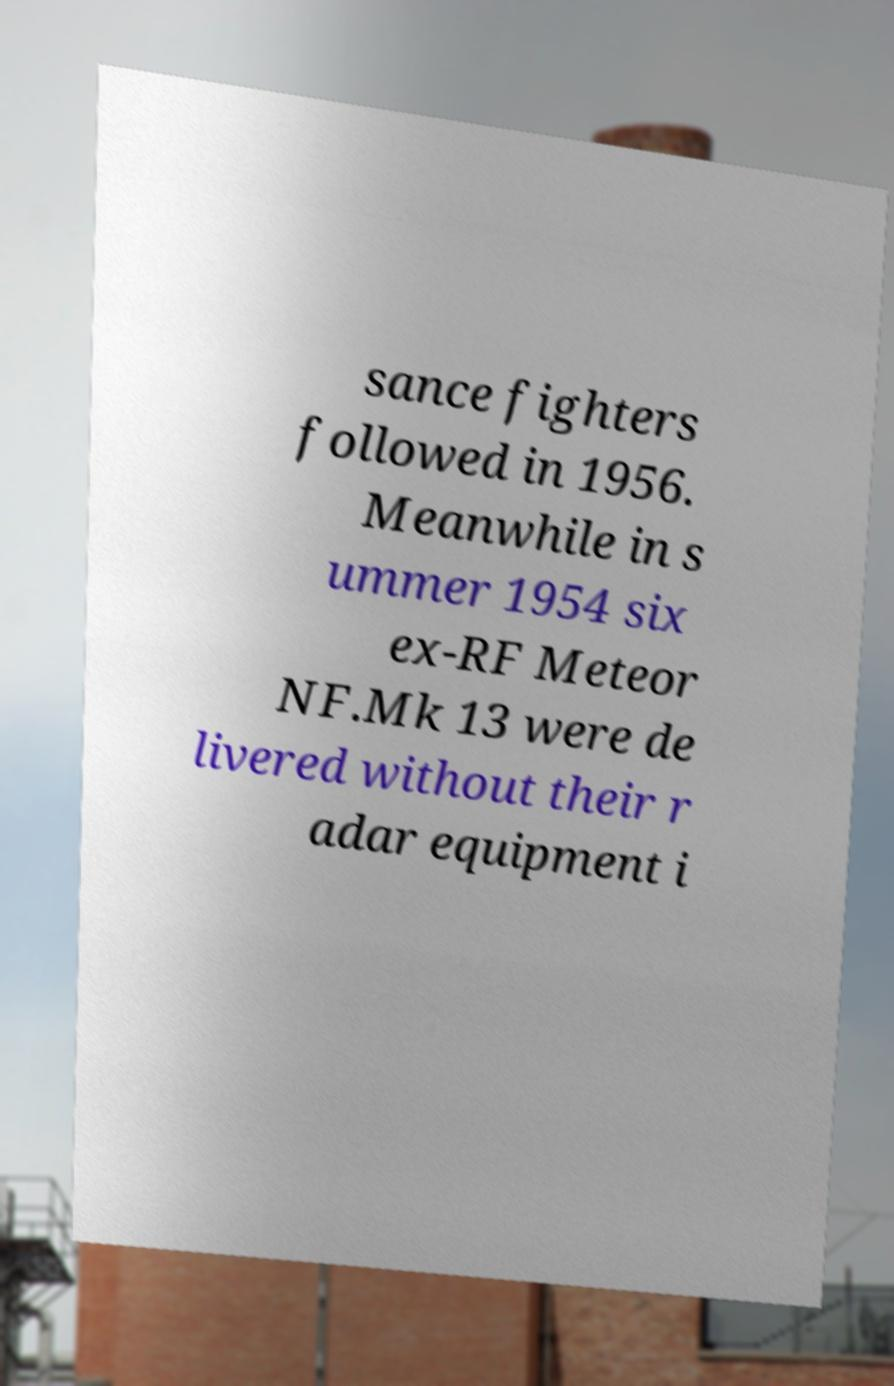Can you read and provide the text displayed in the image?This photo seems to have some interesting text. Can you extract and type it out for me? sance fighters followed in 1956. Meanwhile in s ummer 1954 six ex-RF Meteor NF.Mk 13 were de livered without their r adar equipment i 